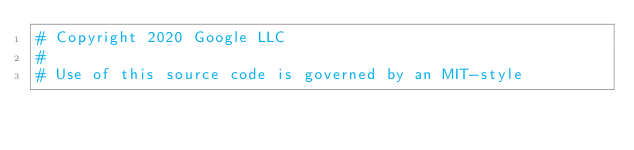Convert code to text. <code><loc_0><loc_0><loc_500><loc_500><_Python_># Copyright 2020 Google LLC
#
# Use of this source code is governed by an MIT-style</code> 